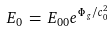Convert formula to latex. <formula><loc_0><loc_0><loc_500><loc_500>E _ { 0 } \, = \, E _ { 0 0 } e ^ { \Phi _ { \, g } / c _ { 0 } ^ { 2 } }</formula> 